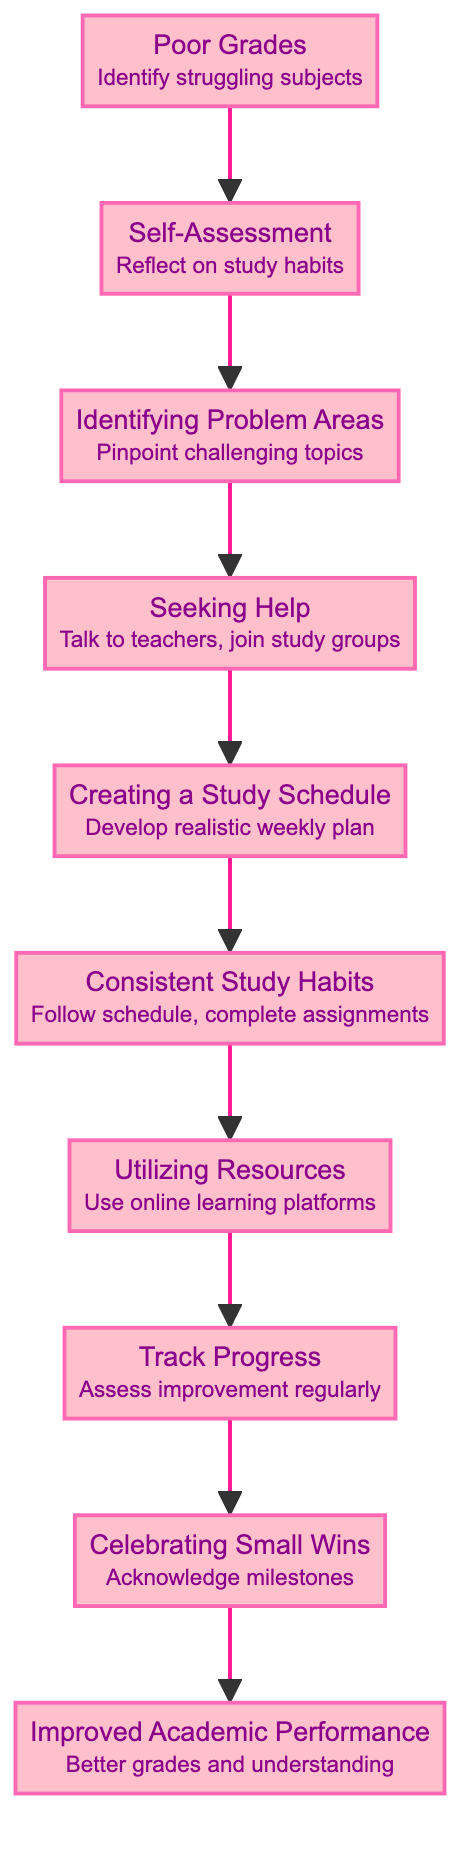What is the first step in the academic improvement journey? The diagram indicates that the first step is identified as "Poor Grades," which is the starting point for the journey to improve academic performance.
Answer: Poor Grades How many total nodes are present in the diagram? The diagram has a total of 10 nodes, starting from "Poor Grades" and ending at "Improved Academic Performance." Each node represents a step in the improvement journey.
Answer: 10 What element follows "Seeking Help"? According to the flow chart, the element that follows "Seeking Help" is "Creating a Study Schedule," indicating the next step after seeking assistance.
Answer: Creating a Study Schedule Which step involves reflecting on study habits? The step that includes reflecting on study habits is "Self-Assessment," as stated in the diagram. It emphasizes evaluating one's own study techniques and time management.
Answer: Self-Assessment What is the ultimate goal of the flow chart? The ultimate goal of the flow chart is "Improved Academic Performance," representing the desired outcome of the entire improvement journey.
Answer: Improved Academic Performance Which two steps come before "Utilizing Resources"? The steps that come immediately before "Utilizing Resources" are "Consistent Study Habits" and "Track Progress." This indicates that consistent habits and tracking progress are key to utilizing resources effectively.
Answer: Consistent Study Habits and Track Progress What are examples of resources mentioned in the diagram? The diagram lists online resources such as "Khan Academy," "Quizlet," and "YouTube tutorials" that can be utilized for extra practice and understanding in various subjects.
Answer: Khan Academy, Quizlet, YouTube tutorials What is required to celebrate in the academic journey? The step titled "Celebrating Small Wins" in the diagram emphasizes the importance of acknowledging and celebrating small milestones throughout the academic improvement journey.
Answer: Celebrating Small Wins How does one track their progress according to the flow chart? Progress can be tracked by regularly assessing improvement through quizzes, practice tests, and obtaining feedback from teachers, as outlined in the corresponding step in the diagram.
Answer: Track Progress 